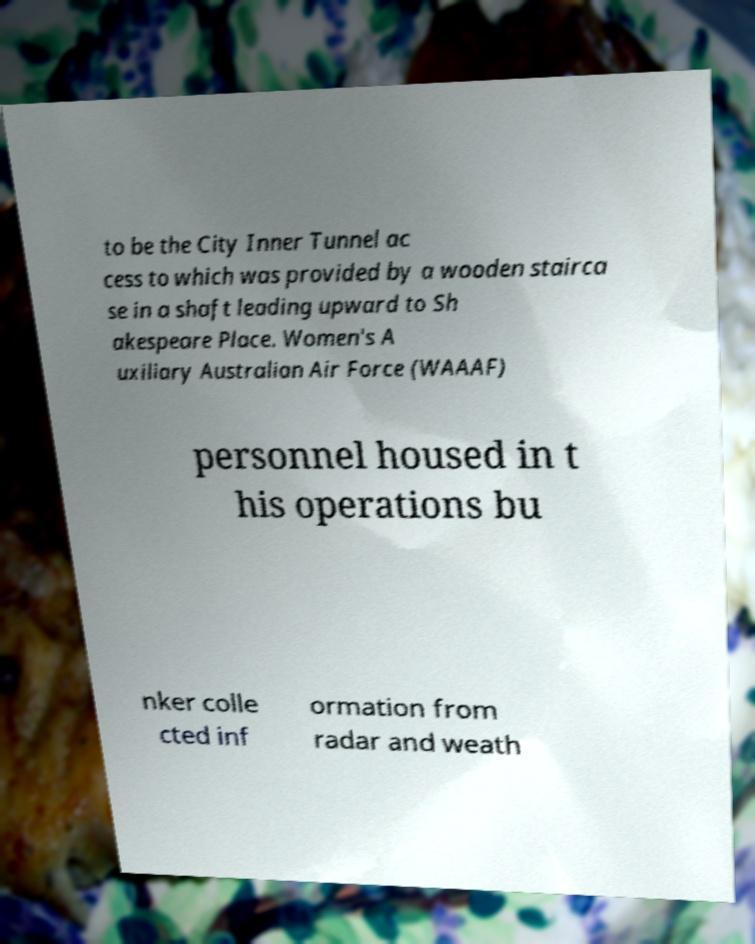For documentation purposes, I need the text within this image transcribed. Could you provide that? to be the City Inner Tunnel ac cess to which was provided by a wooden stairca se in a shaft leading upward to Sh akespeare Place. Women's A uxiliary Australian Air Force (WAAAF) personnel housed in t his operations bu nker colle cted inf ormation from radar and weath 